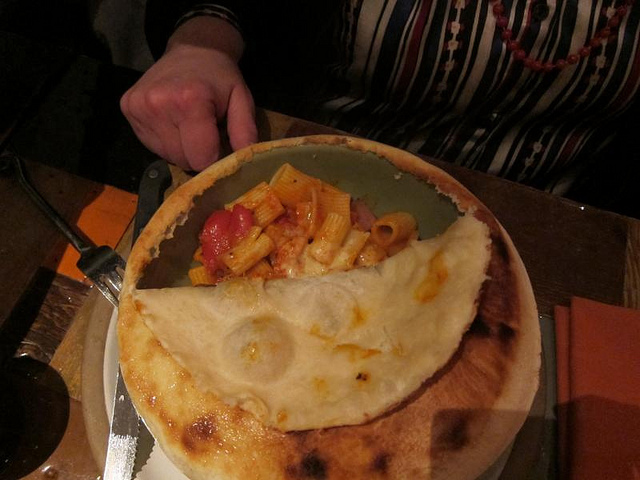<image>Which hand is being used to hold the plate? I am not sure which hand is being used to hold the plate. It could be the right or left hand or none at all. Which hand is being used to hold the plate? It is unanswerable which hand is being used to hold the plate. 